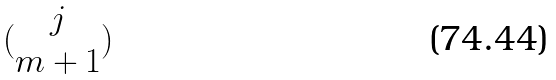Convert formula to latex. <formula><loc_0><loc_0><loc_500><loc_500>( \begin{matrix} j \\ m + 1 \end{matrix} )</formula> 